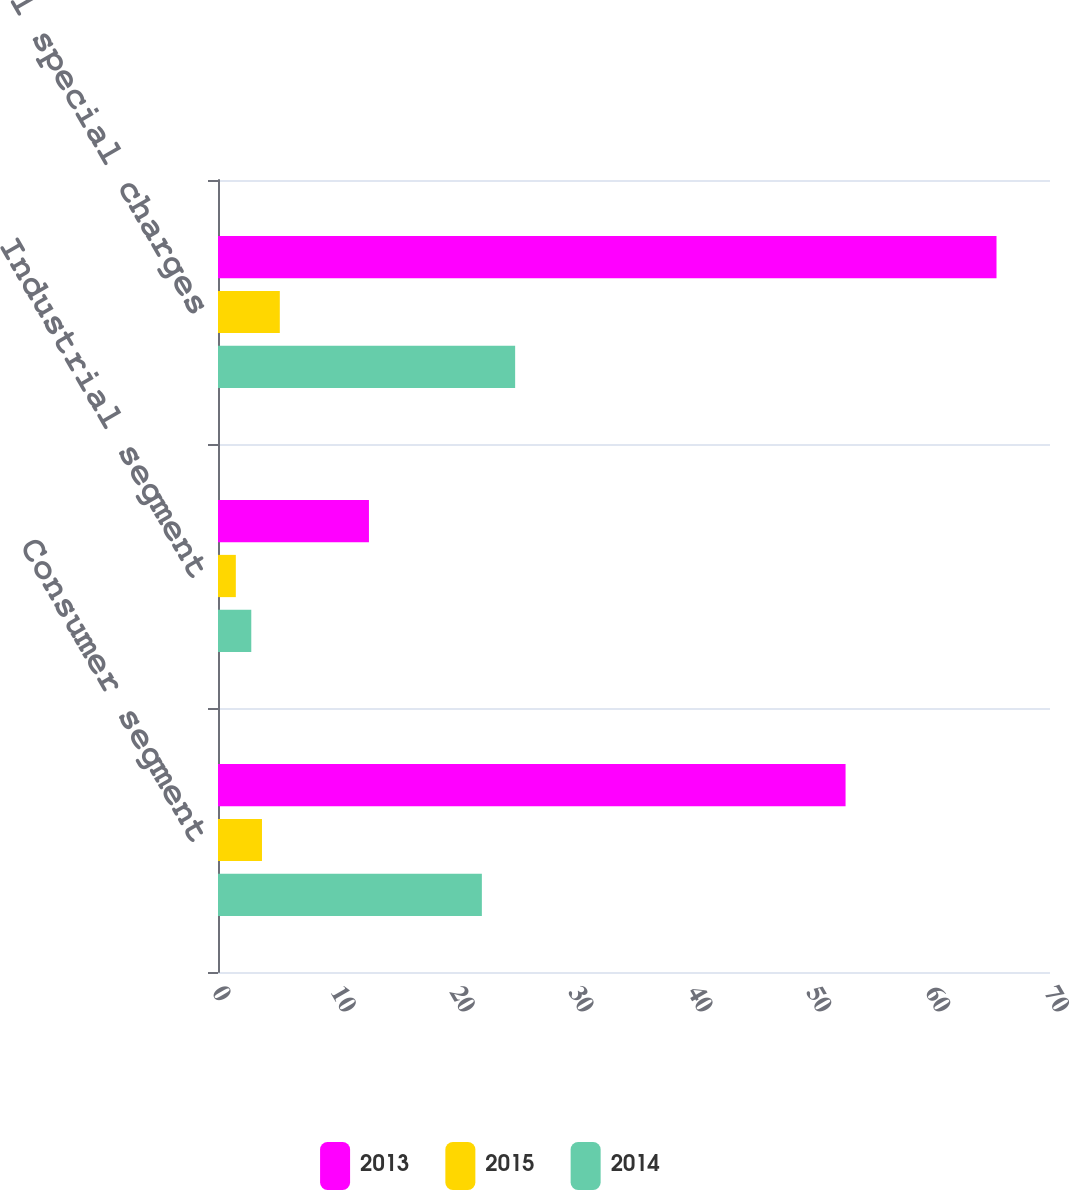Convert chart to OTSL. <chart><loc_0><loc_0><loc_500><loc_500><stacked_bar_chart><ecel><fcel>Consumer segment<fcel>Industrial segment<fcel>Total special charges<nl><fcel>2013<fcel>52.8<fcel>12.7<fcel>65.5<nl><fcel>2015<fcel>3.7<fcel>1.5<fcel>5.2<nl><fcel>2014<fcel>22.2<fcel>2.8<fcel>25<nl></chart> 